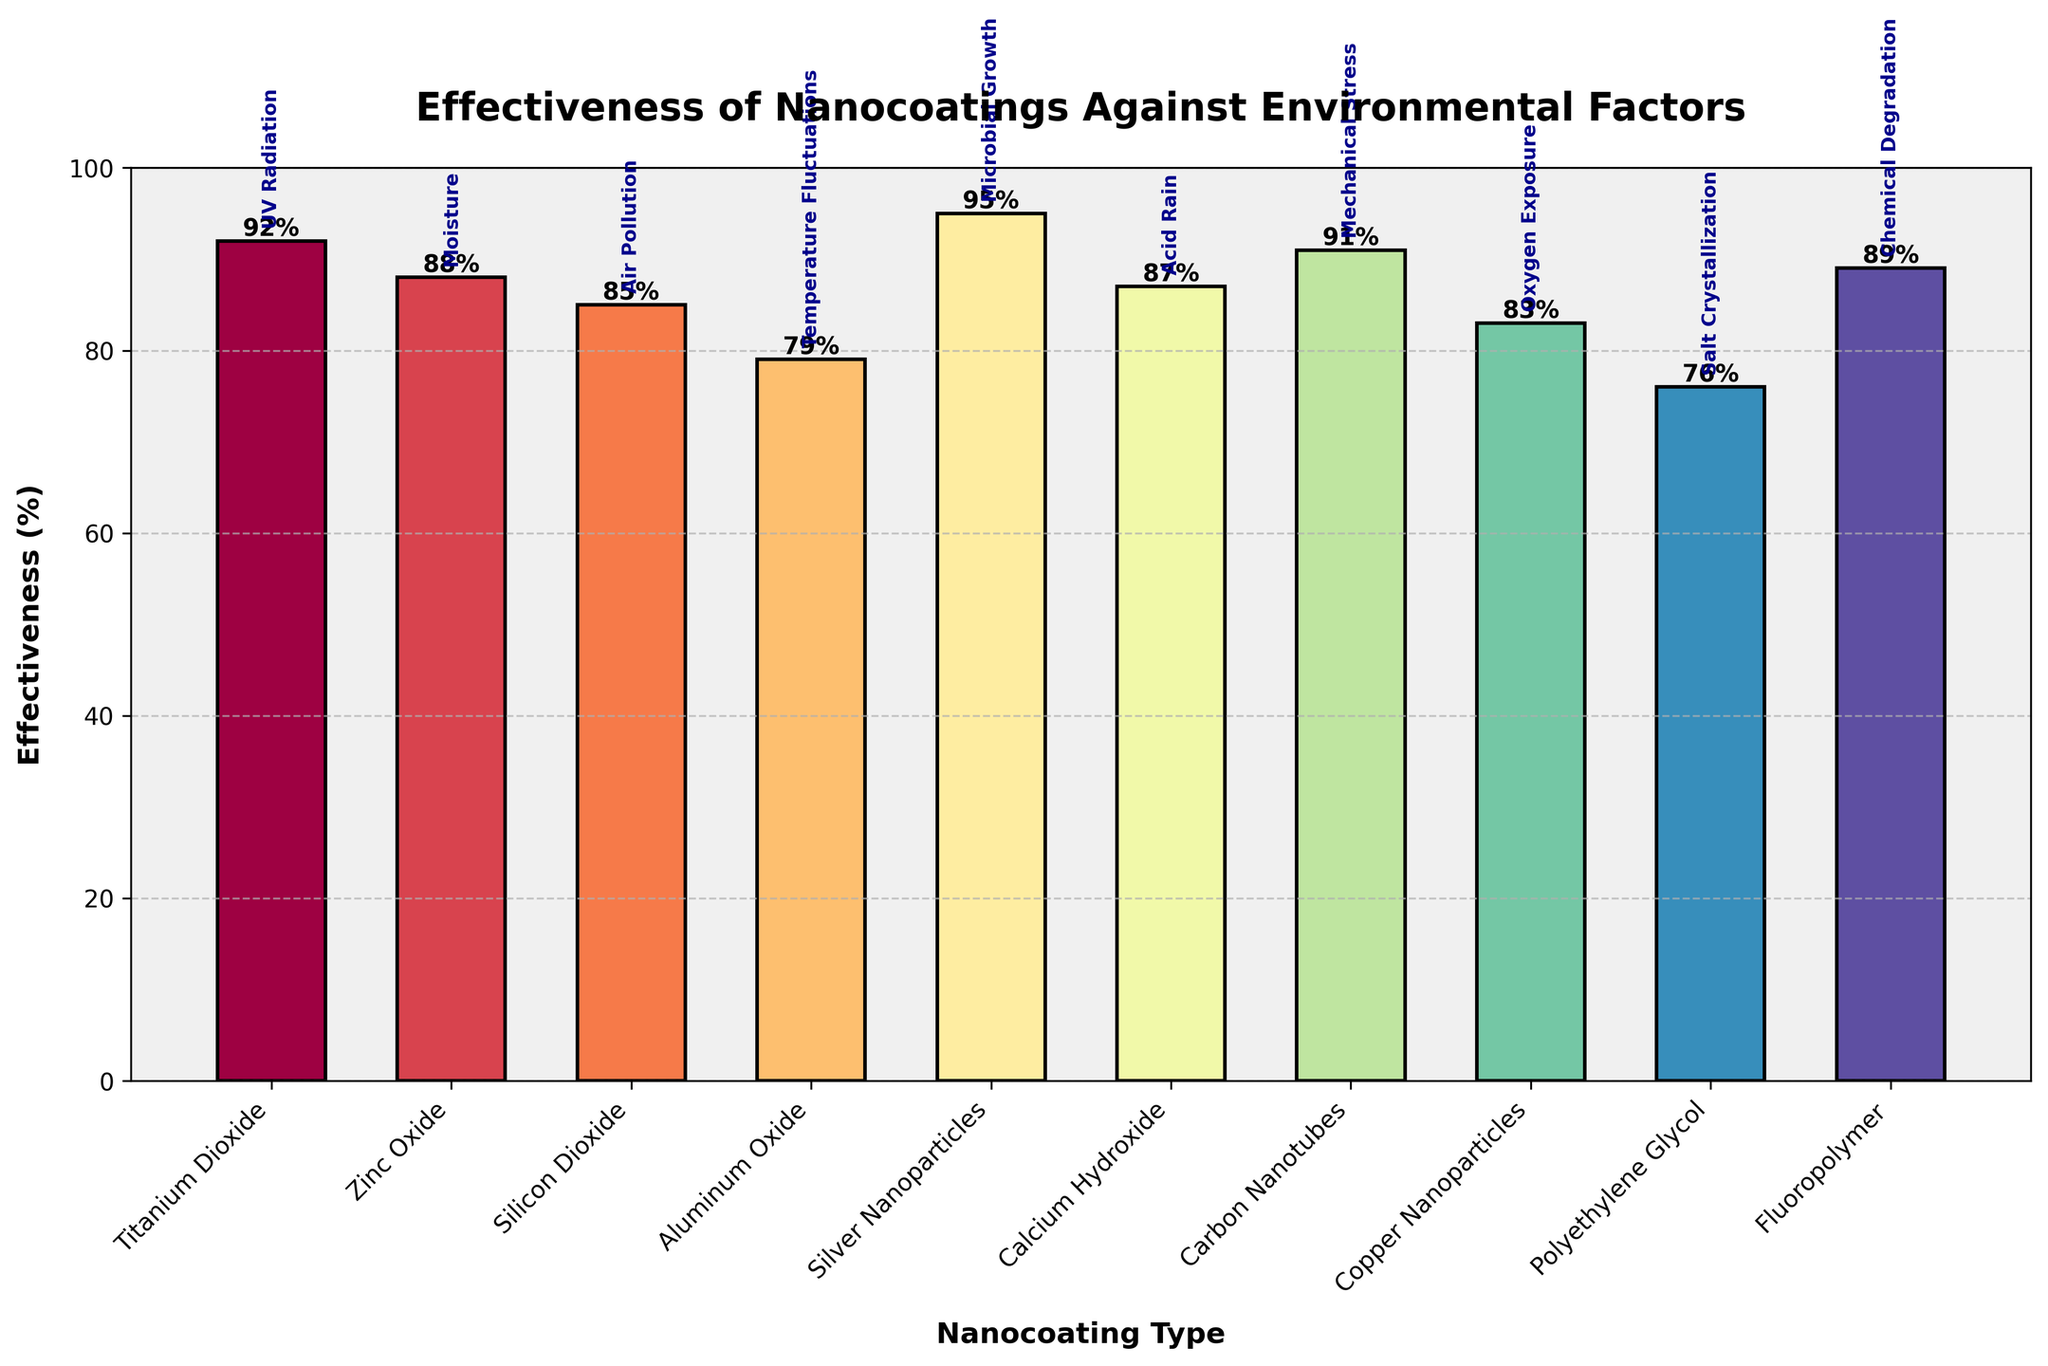Which nanocoating has the highest effectiveness against its environmental factor? The bar representing Silver Nanoparticles against Microbial Growth surpasses all other bars in height, indicating the highest effectiveness.
Answer: Silver Nanoparticles Which nanocoating is the least effective against its respective environmental factor? The bar for Polyethylene Glycol against Salt Crystallization is the shortest among all bars, indicating the lowest effectiveness.
Answer: Polyethylene Glycol What's the average effectiveness of all the nanocoatings? Sum the effectiveness percentages given for all nanocoatings (92 + 88 + 85 + 79 + 95 + 87 + 91 + 83 + 76 + 89) which equals 865. Then, divide by the number of nanocoatings (10). The average effectiveness is 865/10.
Answer: 86.5 How much more effective are Silver Nanoparticles against Microbial Growth compared to Polyethylene Glycol against Salt Crystallization? The effectiveness of Silver Nanoparticles is 95%, and Polyethylene Glycol is 76%. Subtract the two values: 95 - 76.
Answer: 19% Which nanocoating is more effective against Air Pollution: Silicon Dioxide or Copper Nanoparticles? Compare the heights of the bars for Silicon Dioxide (85%) and Copper Nanoparticles (83%). Silicon Dioxide is slightly higher.
Answer: Silicon Dioxide Is Titanium Dioxide more effective against UV Radiation than Aluminum Oxide against Temperature Fluctuations? Titanium Dioxide has an effectiveness of 92%, whereas Aluminum Oxide has an effectiveness of 79%. Since 92% is greater than 79%, Titanium Dioxide is more effective.
Answer: Yes Which nanocoating is shown as the second most effective against its environmental factor? The second tallest bar represents Titanium Dioxide against UV Radiation, with an effectiveness of 92%.
Answer: Titanium Dioxide Calculate the difference in effectiveness between Zinc Oxide and Fluoropolymer. The effectiveness of Zinc Oxide is 88%, and Fluoropolymer is 89%. The difference is 89 - 88.
Answer: 1% What is the median effectiveness of these nanocoatings? To find the median, first sort the effectiveness values: [76, 79, 83, 85, 87, 88, 89, 91, 92, 95]. With 10 values, the median is the average of the 5th and 6th terms: (87 + 88)/2.
Answer: 87.5 By how much does the effectiveness of Fluoropolymer against Chemical Degradation exceed that of Aluminum Oxide against Temperature Fluctuations? The effectiveness of Fluoropolymer is 89%, and for Aluminum Oxide it is 79%. Subtract these values: 89 - 79.
Answer: 10% 